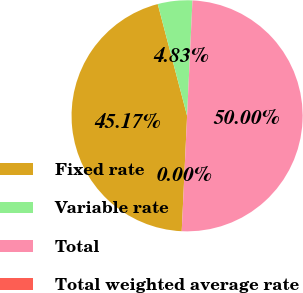Convert chart. <chart><loc_0><loc_0><loc_500><loc_500><pie_chart><fcel>Fixed rate<fcel>Variable rate<fcel>Total<fcel>Total weighted average rate<nl><fcel>45.17%<fcel>4.83%<fcel>50.0%<fcel>0.0%<nl></chart> 